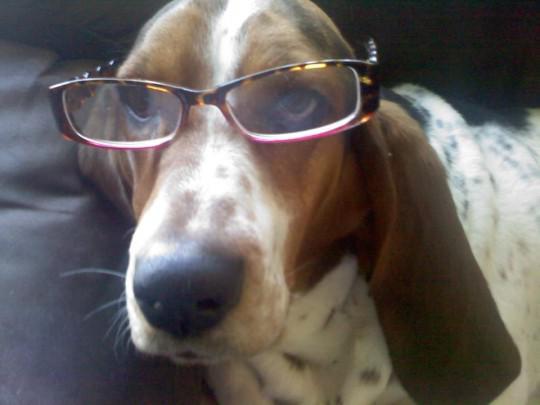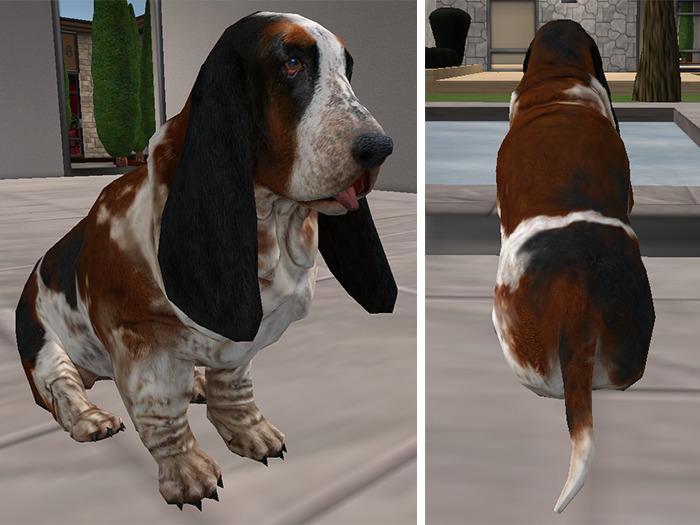The first image is the image on the left, the second image is the image on the right. Evaluate the accuracy of this statement regarding the images: "The image contains a dog with something in his mouth". Is it true? Answer yes or no. No. The first image is the image on the left, the second image is the image on the right. Given the left and right images, does the statement "There are no more than two dogs." hold true? Answer yes or no. No. 